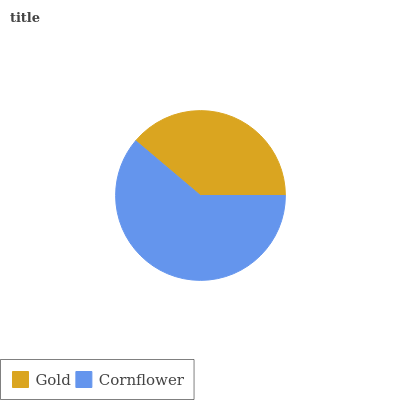Is Gold the minimum?
Answer yes or no. Yes. Is Cornflower the maximum?
Answer yes or no. Yes. Is Cornflower the minimum?
Answer yes or no. No. Is Cornflower greater than Gold?
Answer yes or no. Yes. Is Gold less than Cornflower?
Answer yes or no. Yes. Is Gold greater than Cornflower?
Answer yes or no. No. Is Cornflower less than Gold?
Answer yes or no. No. Is Cornflower the high median?
Answer yes or no. Yes. Is Gold the low median?
Answer yes or no. Yes. Is Gold the high median?
Answer yes or no. No. Is Cornflower the low median?
Answer yes or no. No. 